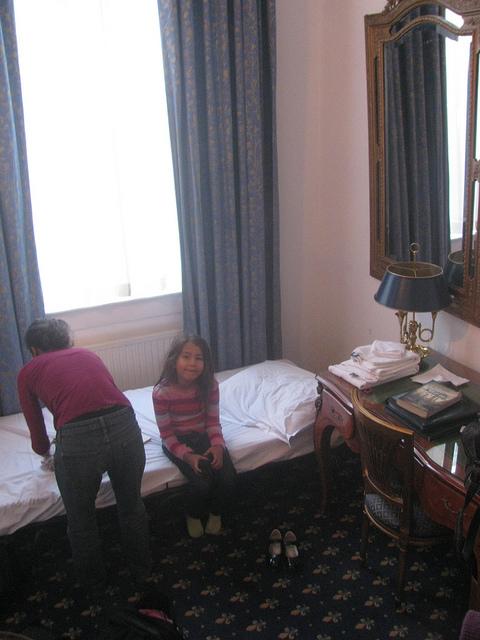How many mirrors?
Concise answer only. 1. How many people in the room?
Give a very brief answer. 2. What is the little girl doing?
Keep it brief. Sitting. 